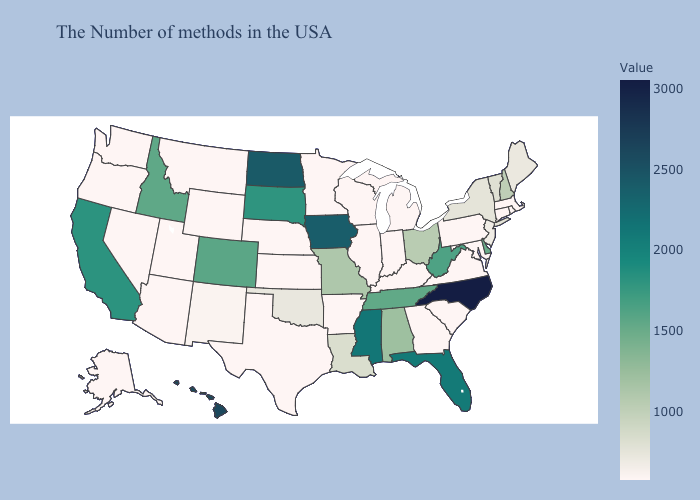Among the states that border Florida , does Georgia have the highest value?
Keep it brief. No. Among the states that border Nevada , which have the highest value?
Write a very short answer. California. Is the legend a continuous bar?
Keep it brief. Yes. Which states have the lowest value in the USA?
Answer briefly. Massachusetts, Rhode Island, Connecticut, Maryland, Pennsylvania, Virginia, South Carolina, Georgia, Michigan, Kentucky, Indiana, Wisconsin, Illinois, Arkansas, Minnesota, Kansas, Nebraska, Texas, Wyoming, Utah, Montana, Arizona, Nevada, Washington, Oregon, Alaska. Does Montana have the lowest value in the West?
Concise answer only. Yes. 